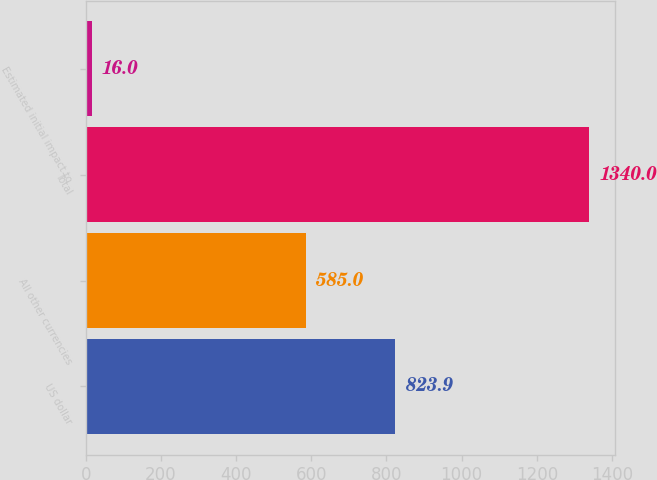Convert chart. <chart><loc_0><loc_0><loc_500><loc_500><bar_chart><fcel>US dollar<fcel>All other currencies<fcel>Total<fcel>Estimated initial impact to<nl><fcel>823.9<fcel>585<fcel>1340<fcel>16<nl></chart> 